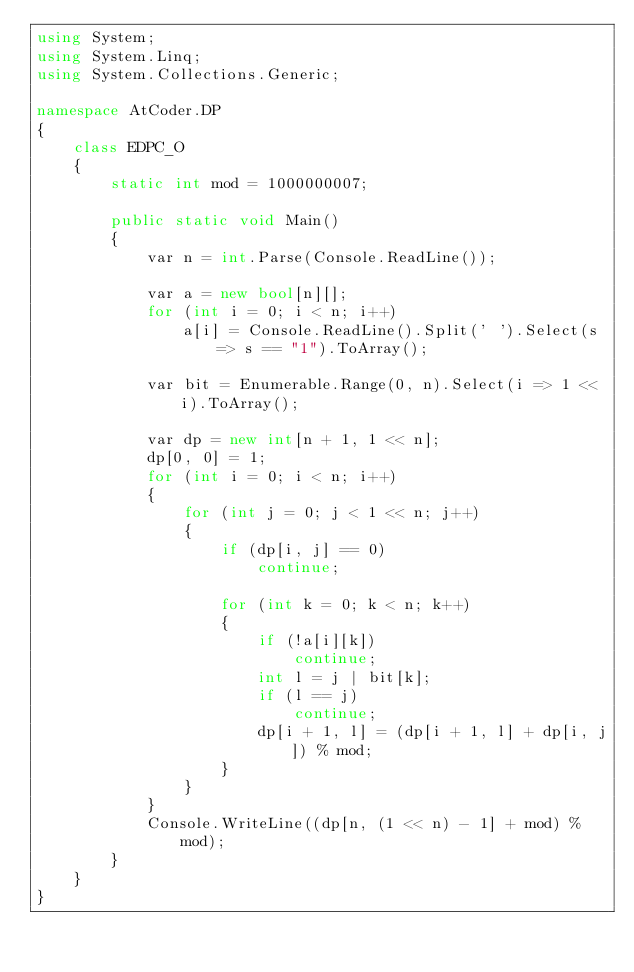<code> <loc_0><loc_0><loc_500><loc_500><_C#_>using System;
using System.Linq;
using System.Collections.Generic;

namespace AtCoder.DP
{
    class EDPC_O
    {
        static int mod = 1000000007;

        public static void Main()
        {
            var n = int.Parse(Console.ReadLine());

            var a = new bool[n][];
            for (int i = 0; i < n; i++)
                a[i] = Console.ReadLine().Split(' ').Select(s => s == "1").ToArray();

            var bit = Enumerable.Range(0, n).Select(i => 1 << i).ToArray();

            var dp = new int[n + 1, 1 << n];
            dp[0, 0] = 1;
            for (int i = 0; i < n; i++)
            {
                for (int j = 0; j < 1 << n; j++)
                {
                    if (dp[i, j] == 0)
                        continue;

                    for (int k = 0; k < n; k++)
                    {
                        if (!a[i][k])
                            continue;
                        int l = j | bit[k];
                        if (l == j)
                            continue;
                        dp[i + 1, l] = (dp[i + 1, l] + dp[i, j]) % mod;
                    }
                }
            }
            Console.WriteLine((dp[n, (1 << n) - 1] + mod) % mod);
        }
    }
}
</code> 